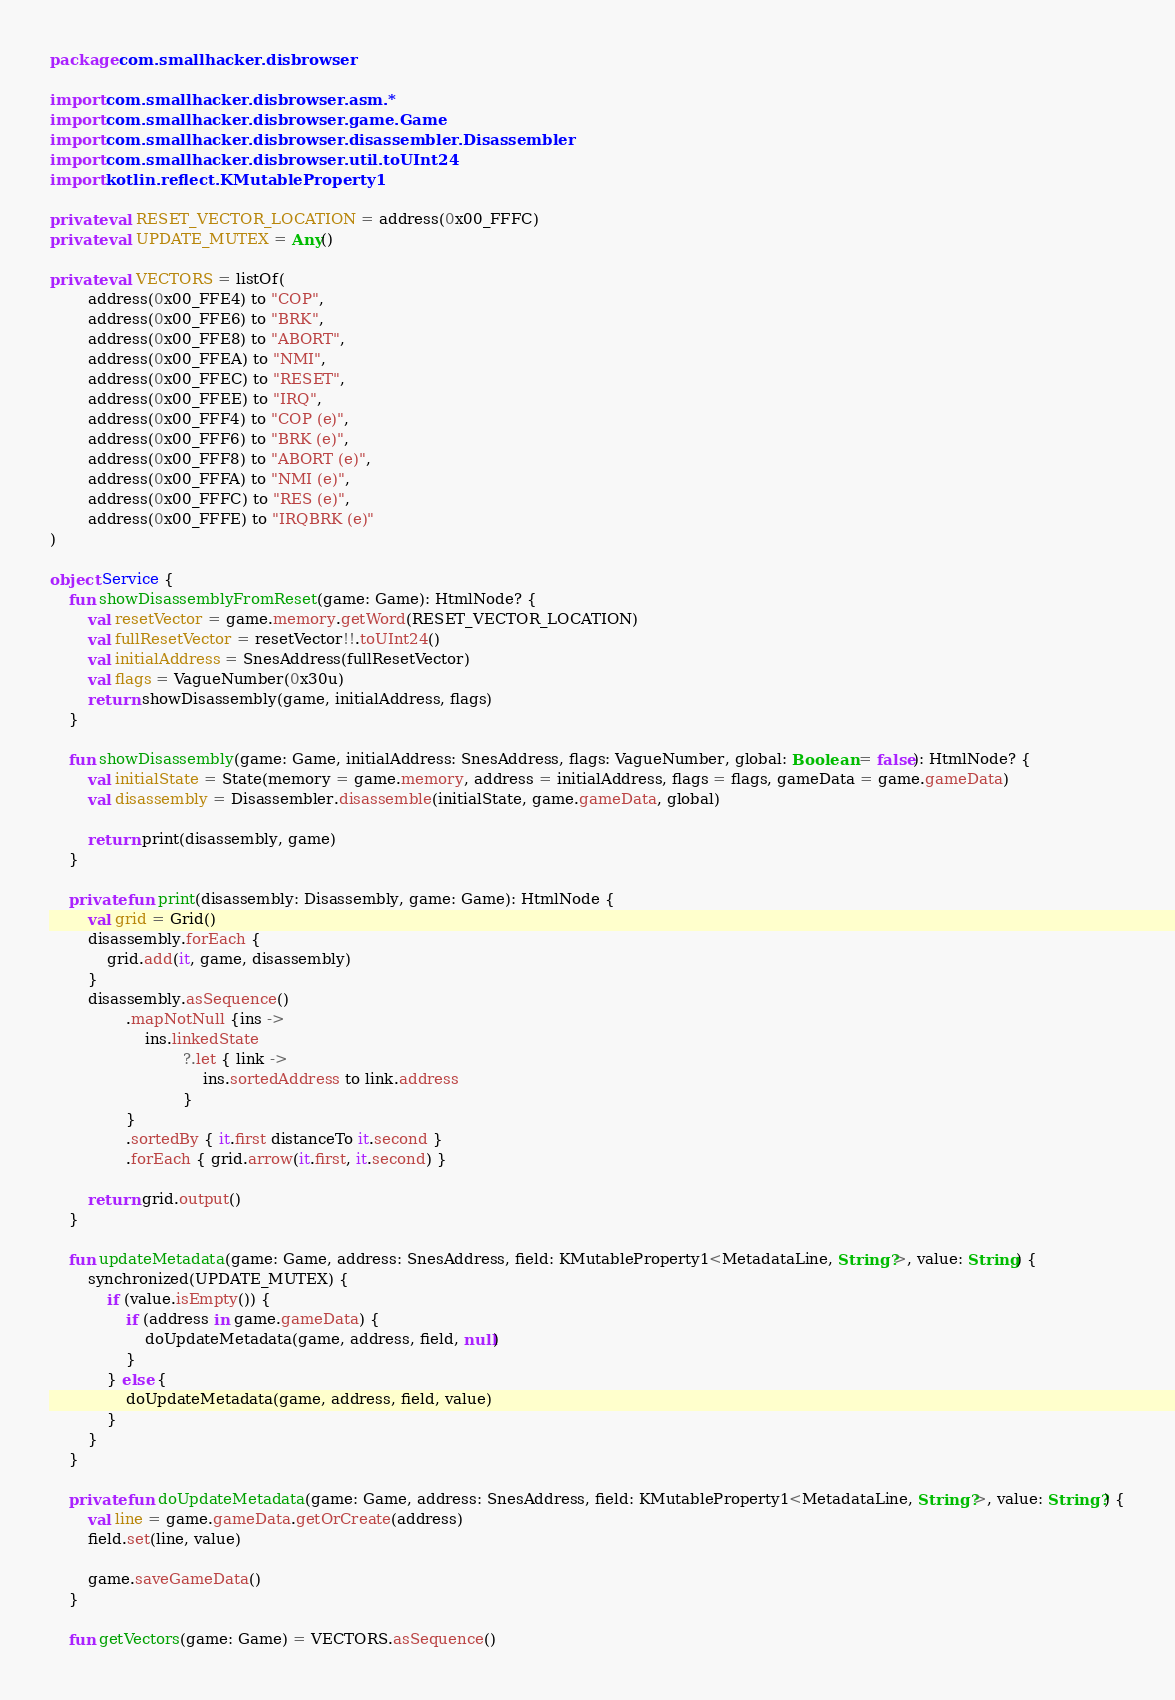Convert code to text. <code><loc_0><loc_0><loc_500><loc_500><_Kotlin_>package com.smallhacker.disbrowser

import com.smallhacker.disbrowser.asm.*
import com.smallhacker.disbrowser.game.Game
import com.smallhacker.disbrowser.disassembler.Disassembler
import com.smallhacker.disbrowser.util.toUInt24
import kotlin.reflect.KMutableProperty1

private val RESET_VECTOR_LOCATION = address(0x00_FFFC)
private val UPDATE_MUTEX = Any()

private val VECTORS = listOf(
        address(0x00_FFE4) to "COP",
        address(0x00_FFE6) to "BRK",
        address(0x00_FFE8) to "ABORT",
        address(0x00_FFEA) to "NMI",
        address(0x00_FFEC) to "RESET",
        address(0x00_FFEE) to "IRQ",
        address(0x00_FFF4) to "COP (e)",
        address(0x00_FFF6) to "BRK (e)",
        address(0x00_FFF8) to "ABORT (e)",
        address(0x00_FFFA) to "NMI (e)",
        address(0x00_FFFC) to "RES (e)",
        address(0x00_FFFE) to "IRQBRK (e)"
)

object Service {
    fun showDisassemblyFromReset(game: Game): HtmlNode? {
        val resetVector = game.memory.getWord(RESET_VECTOR_LOCATION)
        val fullResetVector = resetVector!!.toUInt24()
        val initialAddress = SnesAddress(fullResetVector)
        val flags = VagueNumber(0x30u)
        return showDisassembly(game, initialAddress, flags)
    }

    fun showDisassembly(game: Game, initialAddress: SnesAddress, flags: VagueNumber, global: Boolean = false): HtmlNode? {
        val initialState = State(memory = game.memory, address = initialAddress, flags = flags, gameData = game.gameData)
        val disassembly = Disassembler.disassemble(initialState, game.gameData, global)

        return print(disassembly, game)
    }

    private fun print(disassembly: Disassembly, game: Game): HtmlNode {
        val grid = Grid()
        disassembly.forEach {
            grid.add(it, game, disassembly)
        }
        disassembly.asSequence()
                .mapNotNull {ins ->
                    ins.linkedState
                            ?.let { link ->
                                ins.sortedAddress to link.address
                            }
                }
                .sortedBy { it.first distanceTo it.second }
                .forEach { grid.arrow(it.first, it.second) }

        return grid.output()
    }

    fun updateMetadata(game: Game, address: SnesAddress, field: KMutableProperty1<MetadataLine, String?>, value: String) {
        synchronized(UPDATE_MUTEX) {
            if (value.isEmpty()) {
                if (address in game.gameData) {
                    doUpdateMetadata(game, address, field, null)
                }
            } else {
                doUpdateMetadata(game, address, field, value)
            }
        }
    }

    private fun doUpdateMetadata(game: Game, address: SnesAddress, field: KMutableProperty1<MetadataLine, String?>, value: String?) {
        val line = game.gameData.getOrCreate(address)
        field.set(line, value)

        game.saveGameData()
    }

    fun getVectors(game: Game) = VECTORS.asSequence()</code> 